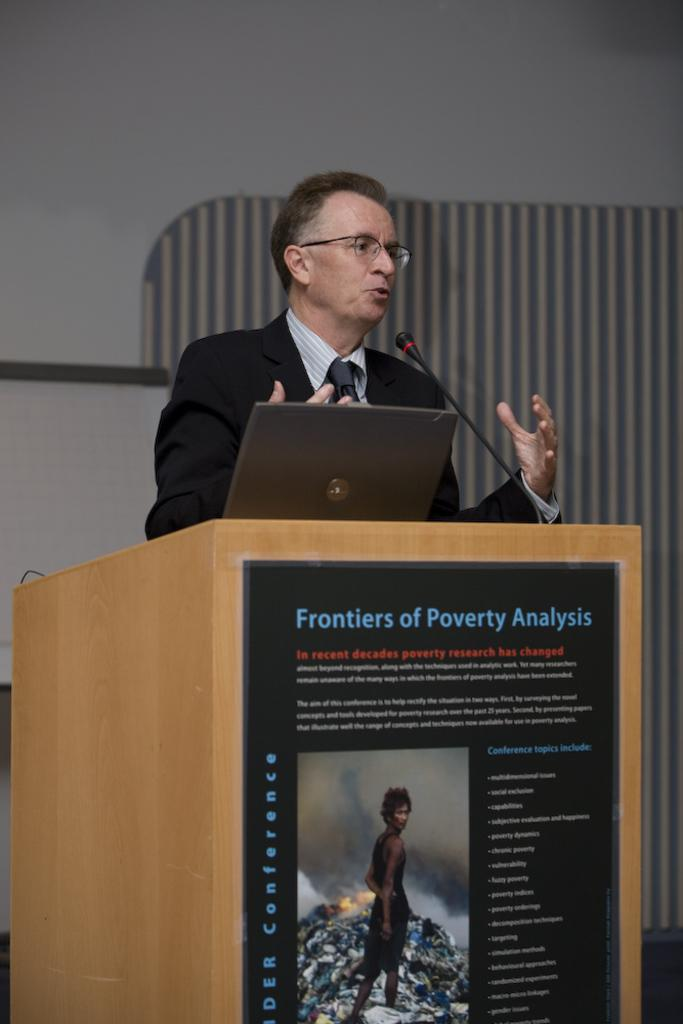Provide a one-sentence caption for the provided image. A guy talking about poverty with a laptop besides him. 